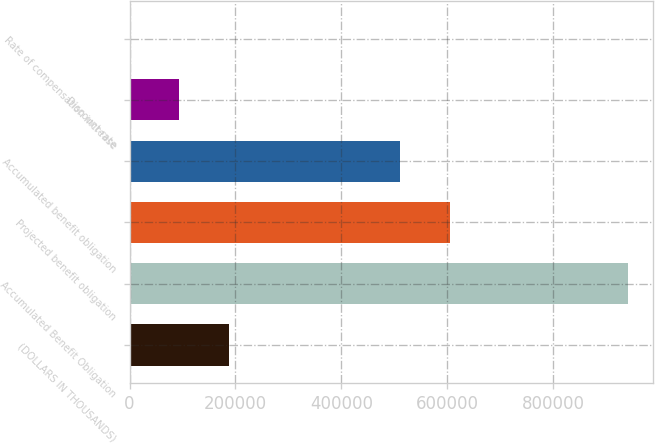Convert chart to OTSL. <chart><loc_0><loc_0><loc_500><loc_500><bar_chart><fcel>(DOLLARS IN THOUSANDS)<fcel>Accumulated Benefit Obligation<fcel>Projected benefit obligation<fcel>Accumulated benefit obligation<fcel>Discount rate<fcel>Rate of compensation increase<nl><fcel>188233<fcel>941158<fcel>605055<fcel>510939<fcel>94117.6<fcel>1.98<nl></chart> 